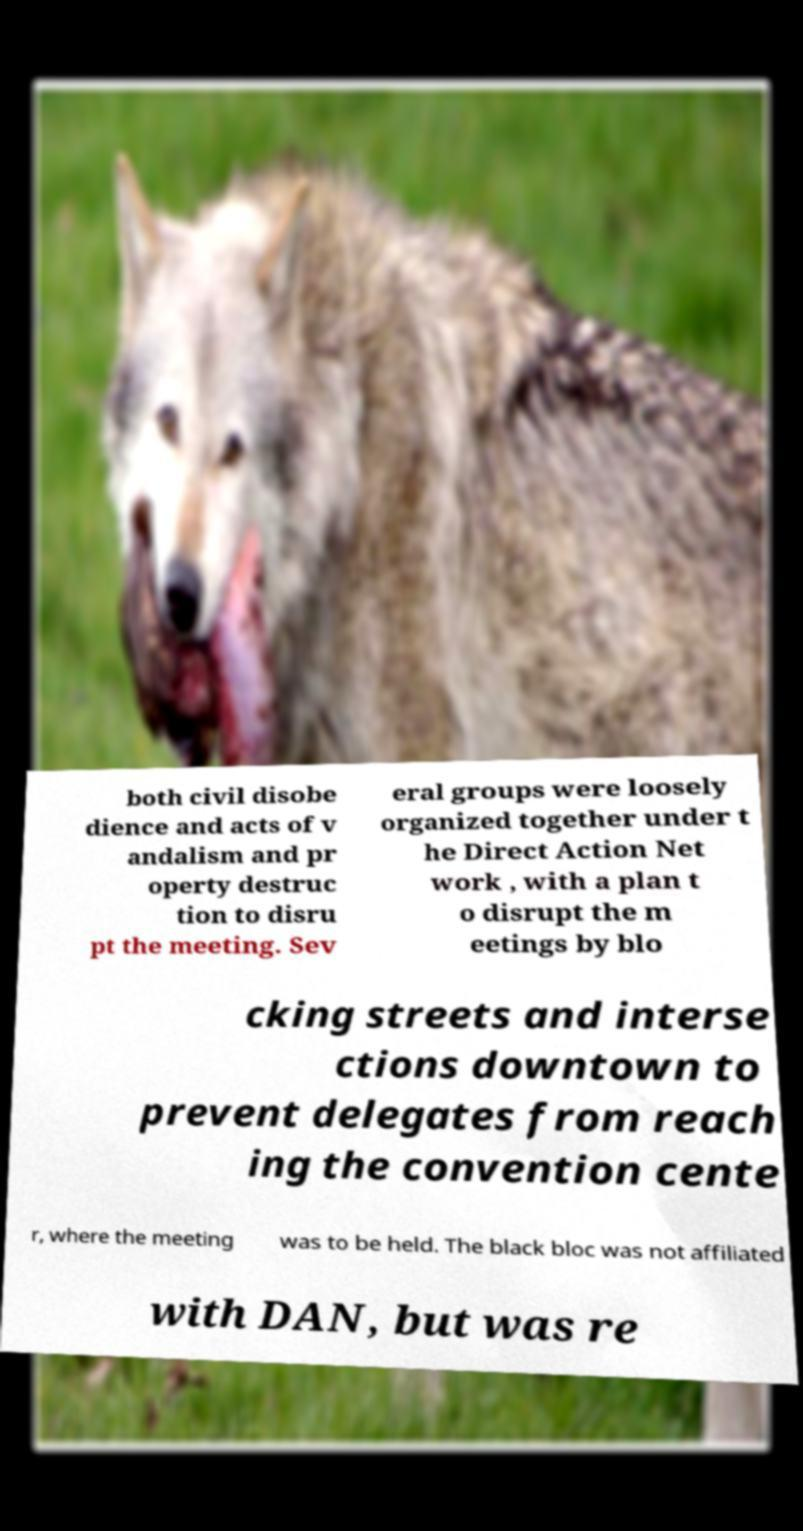Can you read and provide the text displayed in the image?This photo seems to have some interesting text. Can you extract and type it out for me? both civil disobe dience and acts of v andalism and pr operty destruc tion to disru pt the meeting. Sev eral groups were loosely organized together under t he Direct Action Net work , with a plan t o disrupt the m eetings by blo cking streets and interse ctions downtown to prevent delegates from reach ing the convention cente r, where the meeting was to be held. The black bloc was not affiliated with DAN, but was re 